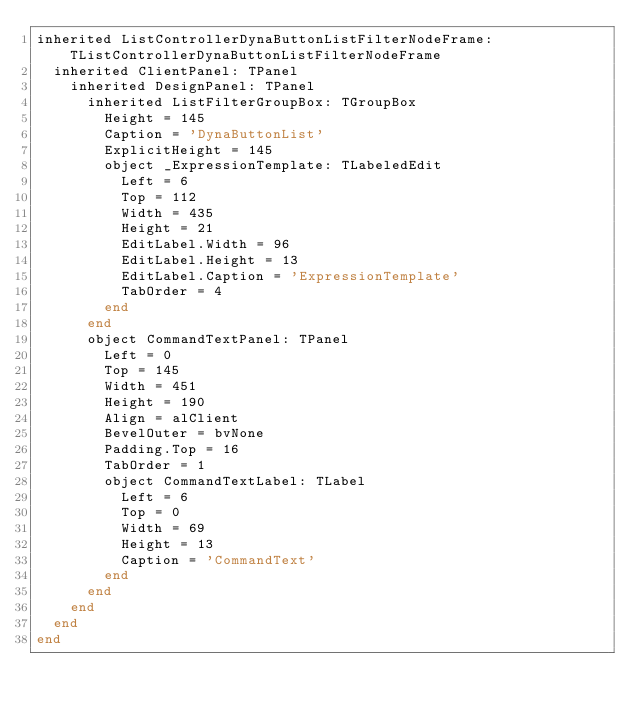Convert code to text. <code><loc_0><loc_0><loc_500><loc_500><_Pascal_>inherited ListControllerDynaButtonListFilterNodeFrame: TListControllerDynaButtonListFilterNodeFrame
  inherited ClientPanel: TPanel
    inherited DesignPanel: TPanel
      inherited ListFilterGroupBox: TGroupBox
        Height = 145
        Caption = 'DynaButtonList'
        ExplicitHeight = 145
        object _ExpressionTemplate: TLabeledEdit
          Left = 6
          Top = 112
          Width = 435
          Height = 21
          EditLabel.Width = 96
          EditLabel.Height = 13
          EditLabel.Caption = 'ExpressionTemplate'
          TabOrder = 4
        end
      end
      object CommandTextPanel: TPanel
        Left = 0
        Top = 145
        Width = 451
        Height = 190
        Align = alClient
        BevelOuter = bvNone
        Padding.Top = 16
        TabOrder = 1
        object CommandTextLabel: TLabel
          Left = 6
          Top = 0
          Width = 69
          Height = 13
          Caption = 'CommandText'
        end
      end
    end
  end
end
</code> 